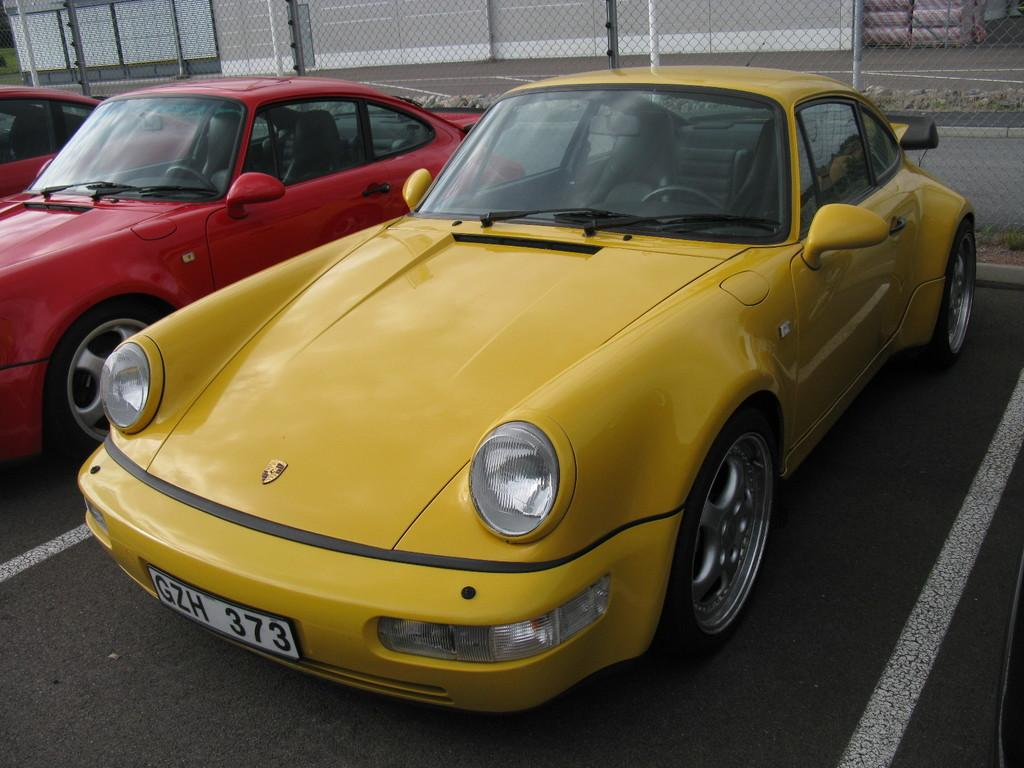What color is the car that stands out in the image? There is a yellow car in the image. How many red cars are present in the image? There are two red cars in the image. Where are the cars located in the image? The cars are on a road. What is visible behind the cars in the image? There is a fence visible behind the cars. Can you tell me how many potatoes are on the tray in the image? There is no tray or potatoes present in the image. What is the starting position of the yellow car in the image? The image does not provide information about the starting position of the yellow car; it only shows the car on the road. 